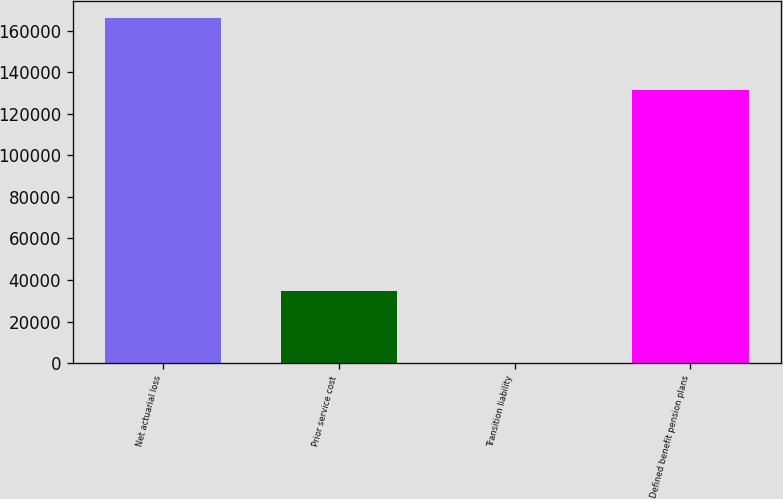Convert chart to OTSL. <chart><loc_0><loc_0><loc_500><loc_500><bar_chart><fcel>Net actuarial loss<fcel>Prior service cost<fcel>Transition liability<fcel>Defined benefit pension plans<nl><fcel>166183<fcel>34688<fcel>6<fcel>131489<nl></chart> 